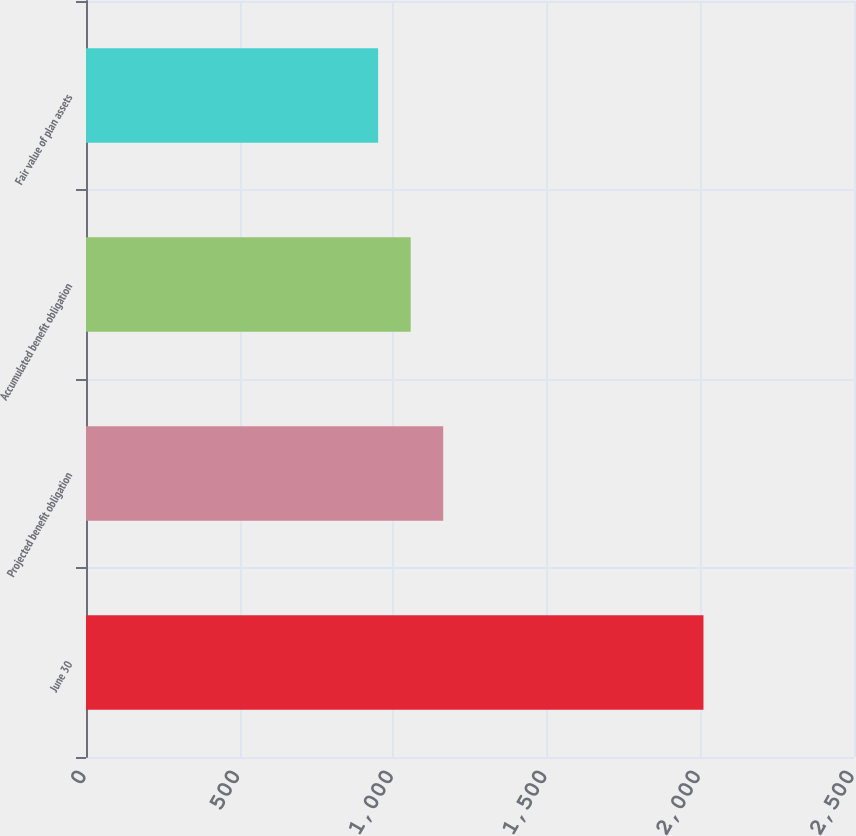Convert chart to OTSL. <chart><loc_0><loc_0><loc_500><loc_500><bar_chart><fcel>June 30<fcel>Projected benefit obligation<fcel>Accumulated benefit obligation<fcel>Fair value of plan assets<nl><fcel>2010<fcel>1162.8<fcel>1056.9<fcel>951<nl></chart> 